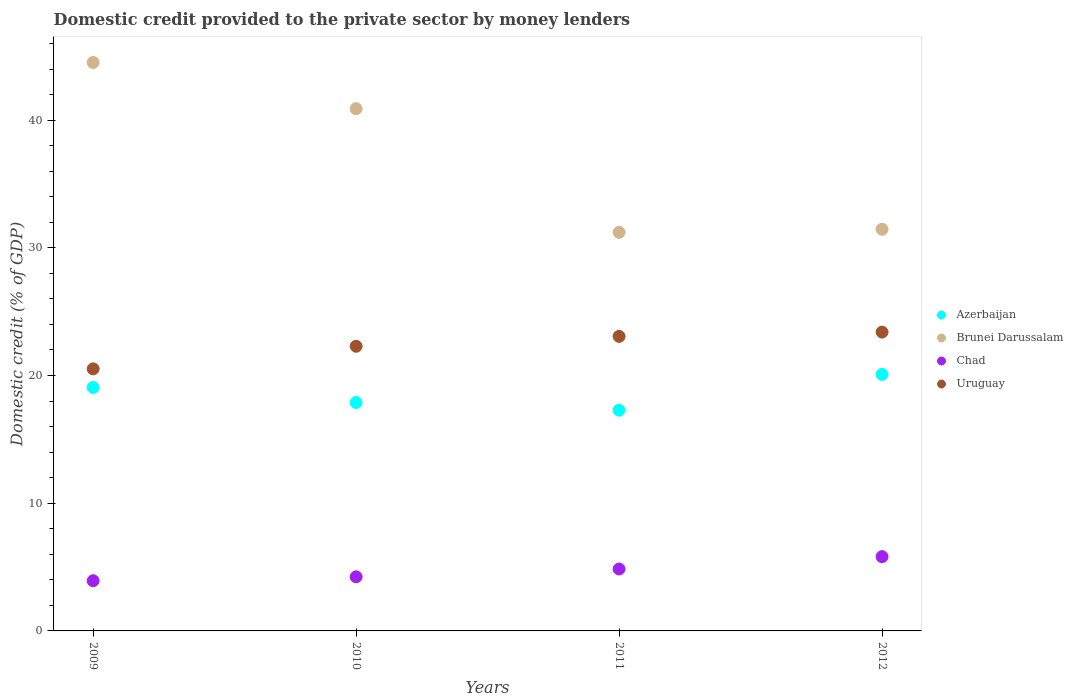How many different coloured dotlines are there?
Your response must be concise. 4. Is the number of dotlines equal to the number of legend labels?
Give a very brief answer. Yes. What is the domestic credit provided to the private sector by money lenders in Uruguay in 2010?
Your answer should be very brief. 22.29. Across all years, what is the maximum domestic credit provided to the private sector by money lenders in Brunei Darussalam?
Offer a terse response. 44.51. Across all years, what is the minimum domestic credit provided to the private sector by money lenders in Azerbaijan?
Give a very brief answer. 17.28. In which year was the domestic credit provided to the private sector by money lenders in Brunei Darussalam minimum?
Offer a terse response. 2011. What is the total domestic credit provided to the private sector by money lenders in Azerbaijan in the graph?
Your answer should be very brief. 74.32. What is the difference between the domestic credit provided to the private sector by money lenders in Uruguay in 2009 and that in 2012?
Offer a terse response. -2.88. What is the difference between the domestic credit provided to the private sector by money lenders in Brunei Darussalam in 2011 and the domestic credit provided to the private sector by money lenders in Azerbaijan in 2009?
Provide a short and direct response. 12.14. What is the average domestic credit provided to the private sector by money lenders in Azerbaijan per year?
Provide a succinct answer. 18.58. In the year 2009, what is the difference between the domestic credit provided to the private sector by money lenders in Chad and domestic credit provided to the private sector by money lenders in Brunei Darussalam?
Your answer should be compact. -40.58. What is the ratio of the domestic credit provided to the private sector by money lenders in Brunei Darussalam in 2009 to that in 2010?
Give a very brief answer. 1.09. Is the domestic credit provided to the private sector by money lenders in Chad in 2011 less than that in 2012?
Ensure brevity in your answer.  Yes. What is the difference between the highest and the second highest domestic credit provided to the private sector by money lenders in Brunei Darussalam?
Provide a short and direct response. 3.62. What is the difference between the highest and the lowest domestic credit provided to the private sector by money lenders in Chad?
Offer a terse response. 1.89. Is the sum of the domestic credit provided to the private sector by money lenders in Brunei Darussalam in 2010 and 2012 greater than the maximum domestic credit provided to the private sector by money lenders in Azerbaijan across all years?
Offer a terse response. Yes. Is it the case that in every year, the sum of the domestic credit provided to the private sector by money lenders in Azerbaijan and domestic credit provided to the private sector by money lenders in Brunei Darussalam  is greater than the domestic credit provided to the private sector by money lenders in Uruguay?
Your response must be concise. Yes. How many dotlines are there?
Your answer should be compact. 4. What is the difference between two consecutive major ticks on the Y-axis?
Offer a terse response. 10. Does the graph contain any zero values?
Provide a succinct answer. No. Where does the legend appear in the graph?
Keep it short and to the point. Center right. How many legend labels are there?
Offer a terse response. 4. What is the title of the graph?
Ensure brevity in your answer.  Domestic credit provided to the private sector by money lenders. Does "Luxembourg" appear as one of the legend labels in the graph?
Keep it short and to the point. No. What is the label or title of the Y-axis?
Ensure brevity in your answer.  Domestic credit (% of GDP). What is the Domestic credit (% of GDP) of Azerbaijan in 2009?
Your answer should be compact. 19.07. What is the Domestic credit (% of GDP) in Brunei Darussalam in 2009?
Offer a terse response. 44.51. What is the Domestic credit (% of GDP) of Chad in 2009?
Your answer should be compact. 3.93. What is the Domestic credit (% of GDP) in Uruguay in 2009?
Keep it short and to the point. 20.52. What is the Domestic credit (% of GDP) of Azerbaijan in 2010?
Offer a terse response. 17.88. What is the Domestic credit (% of GDP) in Brunei Darussalam in 2010?
Give a very brief answer. 40.9. What is the Domestic credit (% of GDP) in Chad in 2010?
Offer a very short reply. 4.24. What is the Domestic credit (% of GDP) in Uruguay in 2010?
Make the answer very short. 22.29. What is the Domestic credit (% of GDP) in Azerbaijan in 2011?
Offer a very short reply. 17.28. What is the Domestic credit (% of GDP) in Brunei Darussalam in 2011?
Give a very brief answer. 31.21. What is the Domestic credit (% of GDP) in Chad in 2011?
Provide a succinct answer. 4.85. What is the Domestic credit (% of GDP) of Uruguay in 2011?
Give a very brief answer. 23.06. What is the Domestic credit (% of GDP) in Azerbaijan in 2012?
Your answer should be compact. 20.09. What is the Domestic credit (% of GDP) in Brunei Darussalam in 2012?
Provide a succinct answer. 31.45. What is the Domestic credit (% of GDP) of Chad in 2012?
Provide a short and direct response. 5.82. What is the Domestic credit (% of GDP) of Uruguay in 2012?
Make the answer very short. 23.4. Across all years, what is the maximum Domestic credit (% of GDP) in Azerbaijan?
Your response must be concise. 20.09. Across all years, what is the maximum Domestic credit (% of GDP) in Brunei Darussalam?
Provide a short and direct response. 44.51. Across all years, what is the maximum Domestic credit (% of GDP) of Chad?
Provide a short and direct response. 5.82. Across all years, what is the maximum Domestic credit (% of GDP) in Uruguay?
Your answer should be compact. 23.4. Across all years, what is the minimum Domestic credit (% of GDP) in Azerbaijan?
Make the answer very short. 17.28. Across all years, what is the minimum Domestic credit (% of GDP) in Brunei Darussalam?
Ensure brevity in your answer.  31.21. Across all years, what is the minimum Domestic credit (% of GDP) in Chad?
Ensure brevity in your answer.  3.93. Across all years, what is the minimum Domestic credit (% of GDP) of Uruguay?
Make the answer very short. 20.52. What is the total Domestic credit (% of GDP) of Azerbaijan in the graph?
Your response must be concise. 74.32. What is the total Domestic credit (% of GDP) in Brunei Darussalam in the graph?
Your response must be concise. 148.07. What is the total Domestic credit (% of GDP) in Chad in the graph?
Provide a short and direct response. 18.83. What is the total Domestic credit (% of GDP) of Uruguay in the graph?
Offer a very short reply. 89.27. What is the difference between the Domestic credit (% of GDP) of Azerbaijan in 2009 and that in 2010?
Ensure brevity in your answer.  1.18. What is the difference between the Domestic credit (% of GDP) in Brunei Darussalam in 2009 and that in 2010?
Your answer should be compact. 3.62. What is the difference between the Domestic credit (% of GDP) in Chad in 2009 and that in 2010?
Your answer should be very brief. -0.31. What is the difference between the Domestic credit (% of GDP) in Uruguay in 2009 and that in 2010?
Your response must be concise. -1.77. What is the difference between the Domestic credit (% of GDP) of Azerbaijan in 2009 and that in 2011?
Keep it short and to the point. 1.78. What is the difference between the Domestic credit (% of GDP) of Brunei Darussalam in 2009 and that in 2011?
Ensure brevity in your answer.  13.3. What is the difference between the Domestic credit (% of GDP) in Chad in 2009 and that in 2011?
Your response must be concise. -0.92. What is the difference between the Domestic credit (% of GDP) in Uruguay in 2009 and that in 2011?
Make the answer very short. -2.54. What is the difference between the Domestic credit (% of GDP) in Azerbaijan in 2009 and that in 2012?
Provide a succinct answer. -1.02. What is the difference between the Domestic credit (% of GDP) in Brunei Darussalam in 2009 and that in 2012?
Keep it short and to the point. 13.06. What is the difference between the Domestic credit (% of GDP) of Chad in 2009 and that in 2012?
Ensure brevity in your answer.  -1.89. What is the difference between the Domestic credit (% of GDP) in Uruguay in 2009 and that in 2012?
Offer a terse response. -2.88. What is the difference between the Domestic credit (% of GDP) in Azerbaijan in 2010 and that in 2011?
Offer a terse response. 0.6. What is the difference between the Domestic credit (% of GDP) of Brunei Darussalam in 2010 and that in 2011?
Your response must be concise. 9.69. What is the difference between the Domestic credit (% of GDP) in Chad in 2010 and that in 2011?
Give a very brief answer. -0.61. What is the difference between the Domestic credit (% of GDP) in Uruguay in 2010 and that in 2011?
Offer a very short reply. -0.78. What is the difference between the Domestic credit (% of GDP) in Azerbaijan in 2010 and that in 2012?
Keep it short and to the point. -2.2. What is the difference between the Domestic credit (% of GDP) in Brunei Darussalam in 2010 and that in 2012?
Your answer should be compact. 9.45. What is the difference between the Domestic credit (% of GDP) of Chad in 2010 and that in 2012?
Your answer should be compact. -1.58. What is the difference between the Domestic credit (% of GDP) in Uruguay in 2010 and that in 2012?
Provide a short and direct response. -1.11. What is the difference between the Domestic credit (% of GDP) of Azerbaijan in 2011 and that in 2012?
Make the answer very short. -2.8. What is the difference between the Domestic credit (% of GDP) in Brunei Darussalam in 2011 and that in 2012?
Your response must be concise. -0.24. What is the difference between the Domestic credit (% of GDP) in Chad in 2011 and that in 2012?
Offer a terse response. -0.97. What is the difference between the Domestic credit (% of GDP) in Uruguay in 2011 and that in 2012?
Offer a very short reply. -0.34. What is the difference between the Domestic credit (% of GDP) of Azerbaijan in 2009 and the Domestic credit (% of GDP) of Brunei Darussalam in 2010?
Provide a succinct answer. -21.83. What is the difference between the Domestic credit (% of GDP) of Azerbaijan in 2009 and the Domestic credit (% of GDP) of Chad in 2010?
Your answer should be compact. 14.83. What is the difference between the Domestic credit (% of GDP) of Azerbaijan in 2009 and the Domestic credit (% of GDP) of Uruguay in 2010?
Offer a very short reply. -3.22. What is the difference between the Domestic credit (% of GDP) of Brunei Darussalam in 2009 and the Domestic credit (% of GDP) of Chad in 2010?
Your answer should be compact. 40.28. What is the difference between the Domestic credit (% of GDP) of Brunei Darussalam in 2009 and the Domestic credit (% of GDP) of Uruguay in 2010?
Ensure brevity in your answer.  22.22. What is the difference between the Domestic credit (% of GDP) in Chad in 2009 and the Domestic credit (% of GDP) in Uruguay in 2010?
Provide a succinct answer. -18.36. What is the difference between the Domestic credit (% of GDP) in Azerbaijan in 2009 and the Domestic credit (% of GDP) in Brunei Darussalam in 2011?
Give a very brief answer. -12.14. What is the difference between the Domestic credit (% of GDP) of Azerbaijan in 2009 and the Domestic credit (% of GDP) of Chad in 2011?
Give a very brief answer. 14.22. What is the difference between the Domestic credit (% of GDP) in Azerbaijan in 2009 and the Domestic credit (% of GDP) in Uruguay in 2011?
Ensure brevity in your answer.  -4. What is the difference between the Domestic credit (% of GDP) of Brunei Darussalam in 2009 and the Domestic credit (% of GDP) of Chad in 2011?
Keep it short and to the point. 39.66. What is the difference between the Domestic credit (% of GDP) of Brunei Darussalam in 2009 and the Domestic credit (% of GDP) of Uruguay in 2011?
Keep it short and to the point. 21.45. What is the difference between the Domestic credit (% of GDP) of Chad in 2009 and the Domestic credit (% of GDP) of Uruguay in 2011?
Offer a very short reply. -19.13. What is the difference between the Domestic credit (% of GDP) of Azerbaijan in 2009 and the Domestic credit (% of GDP) of Brunei Darussalam in 2012?
Provide a short and direct response. -12.38. What is the difference between the Domestic credit (% of GDP) in Azerbaijan in 2009 and the Domestic credit (% of GDP) in Chad in 2012?
Ensure brevity in your answer.  13.25. What is the difference between the Domestic credit (% of GDP) in Azerbaijan in 2009 and the Domestic credit (% of GDP) in Uruguay in 2012?
Provide a succinct answer. -4.33. What is the difference between the Domestic credit (% of GDP) of Brunei Darussalam in 2009 and the Domestic credit (% of GDP) of Chad in 2012?
Offer a terse response. 38.69. What is the difference between the Domestic credit (% of GDP) in Brunei Darussalam in 2009 and the Domestic credit (% of GDP) in Uruguay in 2012?
Offer a terse response. 21.11. What is the difference between the Domestic credit (% of GDP) in Chad in 2009 and the Domestic credit (% of GDP) in Uruguay in 2012?
Your answer should be very brief. -19.47. What is the difference between the Domestic credit (% of GDP) of Azerbaijan in 2010 and the Domestic credit (% of GDP) of Brunei Darussalam in 2011?
Provide a short and direct response. -13.32. What is the difference between the Domestic credit (% of GDP) of Azerbaijan in 2010 and the Domestic credit (% of GDP) of Chad in 2011?
Your answer should be compact. 13.04. What is the difference between the Domestic credit (% of GDP) of Azerbaijan in 2010 and the Domestic credit (% of GDP) of Uruguay in 2011?
Your answer should be very brief. -5.18. What is the difference between the Domestic credit (% of GDP) of Brunei Darussalam in 2010 and the Domestic credit (% of GDP) of Chad in 2011?
Offer a terse response. 36.05. What is the difference between the Domestic credit (% of GDP) in Brunei Darussalam in 2010 and the Domestic credit (% of GDP) in Uruguay in 2011?
Your answer should be very brief. 17.83. What is the difference between the Domestic credit (% of GDP) of Chad in 2010 and the Domestic credit (% of GDP) of Uruguay in 2011?
Make the answer very short. -18.83. What is the difference between the Domestic credit (% of GDP) in Azerbaijan in 2010 and the Domestic credit (% of GDP) in Brunei Darussalam in 2012?
Keep it short and to the point. -13.57. What is the difference between the Domestic credit (% of GDP) in Azerbaijan in 2010 and the Domestic credit (% of GDP) in Chad in 2012?
Offer a terse response. 12.07. What is the difference between the Domestic credit (% of GDP) in Azerbaijan in 2010 and the Domestic credit (% of GDP) in Uruguay in 2012?
Ensure brevity in your answer.  -5.51. What is the difference between the Domestic credit (% of GDP) of Brunei Darussalam in 2010 and the Domestic credit (% of GDP) of Chad in 2012?
Your answer should be compact. 35.08. What is the difference between the Domestic credit (% of GDP) in Brunei Darussalam in 2010 and the Domestic credit (% of GDP) in Uruguay in 2012?
Your response must be concise. 17.5. What is the difference between the Domestic credit (% of GDP) of Chad in 2010 and the Domestic credit (% of GDP) of Uruguay in 2012?
Offer a very short reply. -19.16. What is the difference between the Domestic credit (% of GDP) in Azerbaijan in 2011 and the Domestic credit (% of GDP) in Brunei Darussalam in 2012?
Your response must be concise. -14.17. What is the difference between the Domestic credit (% of GDP) of Azerbaijan in 2011 and the Domestic credit (% of GDP) of Chad in 2012?
Your response must be concise. 11.46. What is the difference between the Domestic credit (% of GDP) of Azerbaijan in 2011 and the Domestic credit (% of GDP) of Uruguay in 2012?
Provide a succinct answer. -6.12. What is the difference between the Domestic credit (% of GDP) in Brunei Darussalam in 2011 and the Domestic credit (% of GDP) in Chad in 2012?
Give a very brief answer. 25.39. What is the difference between the Domestic credit (% of GDP) of Brunei Darussalam in 2011 and the Domestic credit (% of GDP) of Uruguay in 2012?
Keep it short and to the point. 7.81. What is the difference between the Domestic credit (% of GDP) of Chad in 2011 and the Domestic credit (% of GDP) of Uruguay in 2012?
Offer a terse response. -18.55. What is the average Domestic credit (% of GDP) of Azerbaijan per year?
Provide a short and direct response. 18.58. What is the average Domestic credit (% of GDP) in Brunei Darussalam per year?
Offer a terse response. 37.02. What is the average Domestic credit (% of GDP) in Chad per year?
Provide a short and direct response. 4.71. What is the average Domestic credit (% of GDP) of Uruguay per year?
Your answer should be very brief. 22.32. In the year 2009, what is the difference between the Domestic credit (% of GDP) in Azerbaijan and Domestic credit (% of GDP) in Brunei Darussalam?
Offer a very short reply. -25.45. In the year 2009, what is the difference between the Domestic credit (% of GDP) of Azerbaijan and Domestic credit (% of GDP) of Chad?
Your answer should be very brief. 15.14. In the year 2009, what is the difference between the Domestic credit (% of GDP) in Azerbaijan and Domestic credit (% of GDP) in Uruguay?
Provide a short and direct response. -1.46. In the year 2009, what is the difference between the Domestic credit (% of GDP) of Brunei Darussalam and Domestic credit (% of GDP) of Chad?
Offer a very short reply. 40.58. In the year 2009, what is the difference between the Domestic credit (% of GDP) in Brunei Darussalam and Domestic credit (% of GDP) in Uruguay?
Ensure brevity in your answer.  23.99. In the year 2009, what is the difference between the Domestic credit (% of GDP) of Chad and Domestic credit (% of GDP) of Uruguay?
Provide a short and direct response. -16.59. In the year 2010, what is the difference between the Domestic credit (% of GDP) in Azerbaijan and Domestic credit (% of GDP) in Brunei Darussalam?
Provide a short and direct response. -23.01. In the year 2010, what is the difference between the Domestic credit (% of GDP) of Azerbaijan and Domestic credit (% of GDP) of Chad?
Give a very brief answer. 13.65. In the year 2010, what is the difference between the Domestic credit (% of GDP) of Azerbaijan and Domestic credit (% of GDP) of Uruguay?
Ensure brevity in your answer.  -4.4. In the year 2010, what is the difference between the Domestic credit (% of GDP) in Brunei Darussalam and Domestic credit (% of GDP) in Chad?
Make the answer very short. 36.66. In the year 2010, what is the difference between the Domestic credit (% of GDP) in Brunei Darussalam and Domestic credit (% of GDP) in Uruguay?
Keep it short and to the point. 18.61. In the year 2010, what is the difference between the Domestic credit (% of GDP) in Chad and Domestic credit (% of GDP) in Uruguay?
Make the answer very short. -18.05. In the year 2011, what is the difference between the Domestic credit (% of GDP) in Azerbaijan and Domestic credit (% of GDP) in Brunei Darussalam?
Your response must be concise. -13.93. In the year 2011, what is the difference between the Domestic credit (% of GDP) of Azerbaijan and Domestic credit (% of GDP) of Chad?
Offer a terse response. 12.43. In the year 2011, what is the difference between the Domestic credit (% of GDP) in Azerbaijan and Domestic credit (% of GDP) in Uruguay?
Provide a succinct answer. -5.78. In the year 2011, what is the difference between the Domestic credit (% of GDP) of Brunei Darussalam and Domestic credit (% of GDP) of Chad?
Your response must be concise. 26.36. In the year 2011, what is the difference between the Domestic credit (% of GDP) in Brunei Darussalam and Domestic credit (% of GDP) in Uruguay?
Offer a very short reply. 8.15. In the year 2011, what is the difference between the Domestic credit (% of GDP) of Chad and Domestic credit (% of GDP) of Uruguay?
Ensure brevity in your answer.  -18.22. In the year 2012, what is the difference between the Domestic credit (% of GDP) in Azerbaijan and Domestic credit (% of GDP) in Brunei Darussalam?
Keep it short and to the point. -11.36. In the year 2012, what is the difference between the Domestic credit (% of GDP) in Azerbaijan and Domestic credit (% of GDP) in Chad?
Give a very brief answer. 14.27. In the year 2012, what is the difference between the Domestic credit (% of GDP) of Azerbaijan and Domestic credit (% of GDP) of Uruguay?
Give a very brief answer. -3.31. In the year 2012, what is the difference between the Domestic credit (% of GDP) of Brunei Darussalam and Domestic credit (% of GDP) of Chad?
Provide a short and direct response. 25.63. In the year 2012, what is the difference between the Domestic credit (% of GDP) in Brunei Darussalam and Domestic credit (% of GDP) in Uruguay?
Keep it short and to the point. 8.05. In the year 2012, what is the difference between the Domestic credit (% of GDP) of Chad and Domestic credit (% of GDP) of Uruguay?
Offer a terse response. -17.58. What is the ratio of the Domestic credit (% of GDP) of Azerbaijan in 2009 to that in 2010?
Your answer should be compact. 1.07. What is the ratio of the Domestic credit (% of GDP) of Brunei Darussalam in 2009 to that in 2010?
Offer a terse response. 1.09. What is the ratio of the Domestic credit (% of GDP) in Chad in 2009 to that in 2010?
Keep it short and to the point. 0.93. What is the ratio of the Domestic credit (% of GDP) in Uruguay in 2009 to that in 2010?
Ensure brevity in your answer.  0.92. What is the ratio of the Domestic credit (% of GDP) in Azerbaijan in 2009 to that in 2011?
Your response must be concise. 1.1. What is the ratio of the Domestic credit (% of GDP) of Brunei Darussalam in 2009 to that in 2011?
Make the answer very short. 1.43. What is the ratio of the Domestic credit (% of GDP) of Chad in 2009 to that in 2011?
Your answer should be very brief. 0.81. What is the ratio of the Domestic credit (% of GDP) in Uruguay in 2009 to that in 2011?
Your answer should be very brief. 0.89. What is the ratio of the Domestic credit (% of GDP) in Azerbaijan in 2009 to that in 2012?
Your answer should be compact. 0.95. What is the ratio of the Domestic credit (% of GDP) in Brunei Darussalam in 2009 to that in 2012?
Give a very brief answer. 1.42. What is the ratio of the Domestic credit (% of GDP) of Chad in 2009 to that in 2012?
Your answer should be very brief. 0.68. What is the ratio of the Domestic credit (% of GDP) of Uruguay in 2009 to that in 2012?
Your answer should be very brief. 0.88. What is the ratio of the Domestic credit (% of GDP) in Azerbaijan in 2010 to that in 2011?
Your answer should be compact. 1.03. What is the ratio of the Domestic credit (% of GDP) of Brunei Darussalam in 2010 to that in 2011?
Offer a terse response. 1.31. What is the ratio of the Domestic credit (% of GDP) in Chad in 2010 to that in 2011?
Your answer should be very brief. 0.87. What is the ratio of the Domestic credit (% of GDP) in Uruguay in 2010 to that in 2011?
Provide a succinct answer. 0.97. What is the ratio of the Domestic credit (% of GDP) of Azerbaijan in 2010 to that in 2012?
Ensure brevity in your answer.  0.89. What is the ratio of the Domestic credit (% of GDP) of Brunei Darussalam in 2010 to that in 2012?
Your response must be concise. 1.3. What is the ratio of the Domestic credit (% of GDP) of Chad in 2010 to that in 2012?
Ensure brevity in your answer.  0.73. What is the ratio of the Domestic credit (% of GDP) of Uruguay in 2010 to that in 2012?
Make the answer very short. 0.95. What is the ratio of the Domestic credit (% of GDP) of Azerbaijan in 2011 to that in 2012?
Your answer should be very brief. 0.86. What is the ratio of the Domestic credit (% of GDP) in Brunei Darussalam in 2011 to that in 2012?
Provide a succinct answer. 0.99. What is the ratio of the Domestic credit (% of GDP) of Chad in 2011 to that in 2012?
Your answer should be very brief. 0.83. What is the ratio of the Domestic credit (% of GDP) in Uruguay in 2011 to that in 2012?
Your answer should be very brief. 0.99. What is the difference between the highest and the second highest Domestic credit (% of GDP) of Azerbaijan?
Ensure brevity in your answer.  1.02. What is the difference between the highest and the second highest Domestic credit (% of GDP) in Brunei Darussalam?
Ensure brevity in your answer.  3.62. What is the difference between the highest and the second highest Domestic credit (% of GDP) in Chad?
Offer a terse response. 0.97. What is the difference between the highest and the second highest Domestic credit (% of GDP) of Uruguay?
Keep it short and to the point. 0.34. What is the difference between the highest and the lowest Domestic credit (% of GDP) in Azerbaijan?
Offer a terse response. 2.8. What is the difference between the highest and the lowest Domestic credit (% of GDP) of Brunei Darussalam?
Your answer should be very brief. 13.3. What is the difference between the highest and the lowest Domestic credit (% of GDP) of Chad?
Your answer should be compact. 1.89. What is the difference between the highest and the lowest Domestic credit (% of GDP) of Uruguay?
Your answer should be compact. 2.88. 